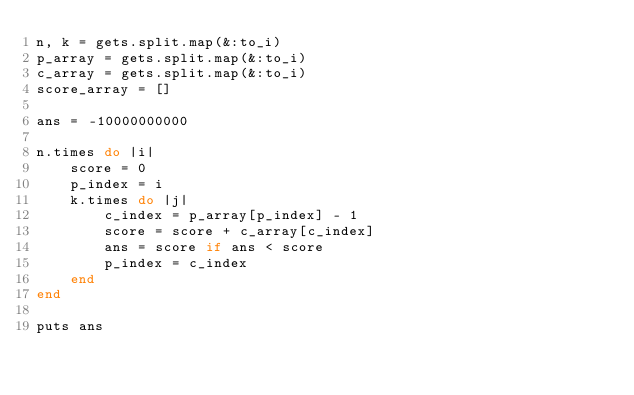Convert code to text. <code><loc_0><loc_0><loc_500><loc_500><_Ruby_>n, k = gets.split.map(&:to_i)
p_array = gets.split.map(&:to_i)
c_array = gets.split.map(&:to_i)
score_array = []

ans = -10000000000

n.times do |i|
    score = 0
    p_index = i
    k.times do |j|
        c_index = p_array[p_index] - 1
        score = score + c_array[c_index]
        ans = score if ans < score
        p_index = c_index
    end
end

puts ans
</code> 